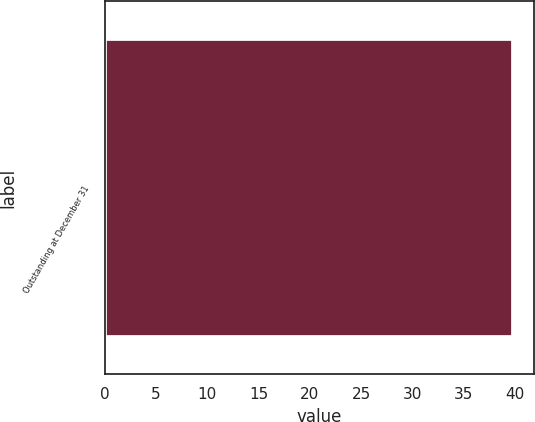Convert chart to OTSL. <chart><loc_0><loc_0><loc_500><loc_500><bar_chart><fcel>Outstanding at December 31<nl><fcel>39.81<nl></chart> 